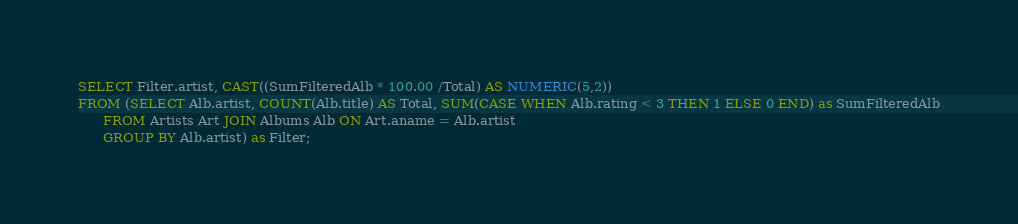<code> <loc_0><loc_0><loc_500><loc_500><_SQL_>SELECT Filter.artist, CAST((SumFilteredAlb * 100.00 /Total) AS NUMERIC(5,2))
FROM (SELECT Alb.artist, COUNT(Alb.title) AS Total, SUM(CASE WHEN Alb.rating < 3 THEN 1 ELSE 0 END) as SumFilteredAlb
      FROM Artists Art JOIN Albums Alb ON Art.aname = Alb.artist
      GROUP BY Alb.artist) as Filter;</code> 